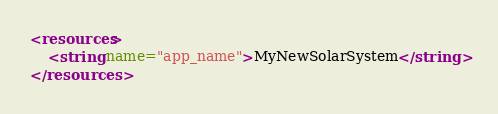<code> <loc_0><loc_0><loc_500><loc_500><_XML_><resources>
    <string name="app_name">MyNewSolarSystem</string>
</resources>
</code> 